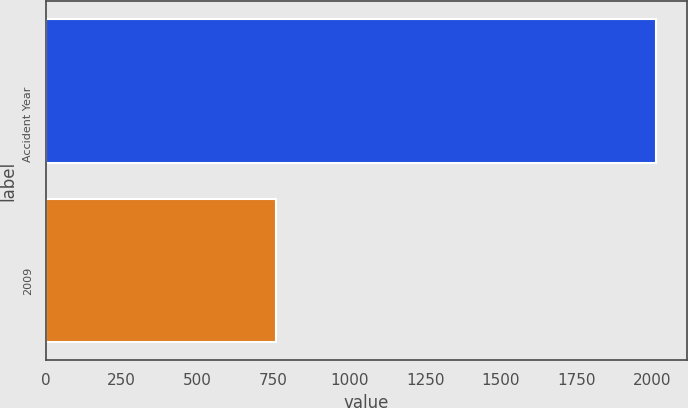<chart> <loc_0><loc_0><loc_500><loc_500><bar_chart><fcel>Accident Year<fcel>2009<nl><fcel>2012<fcel>759<nl></chart> 